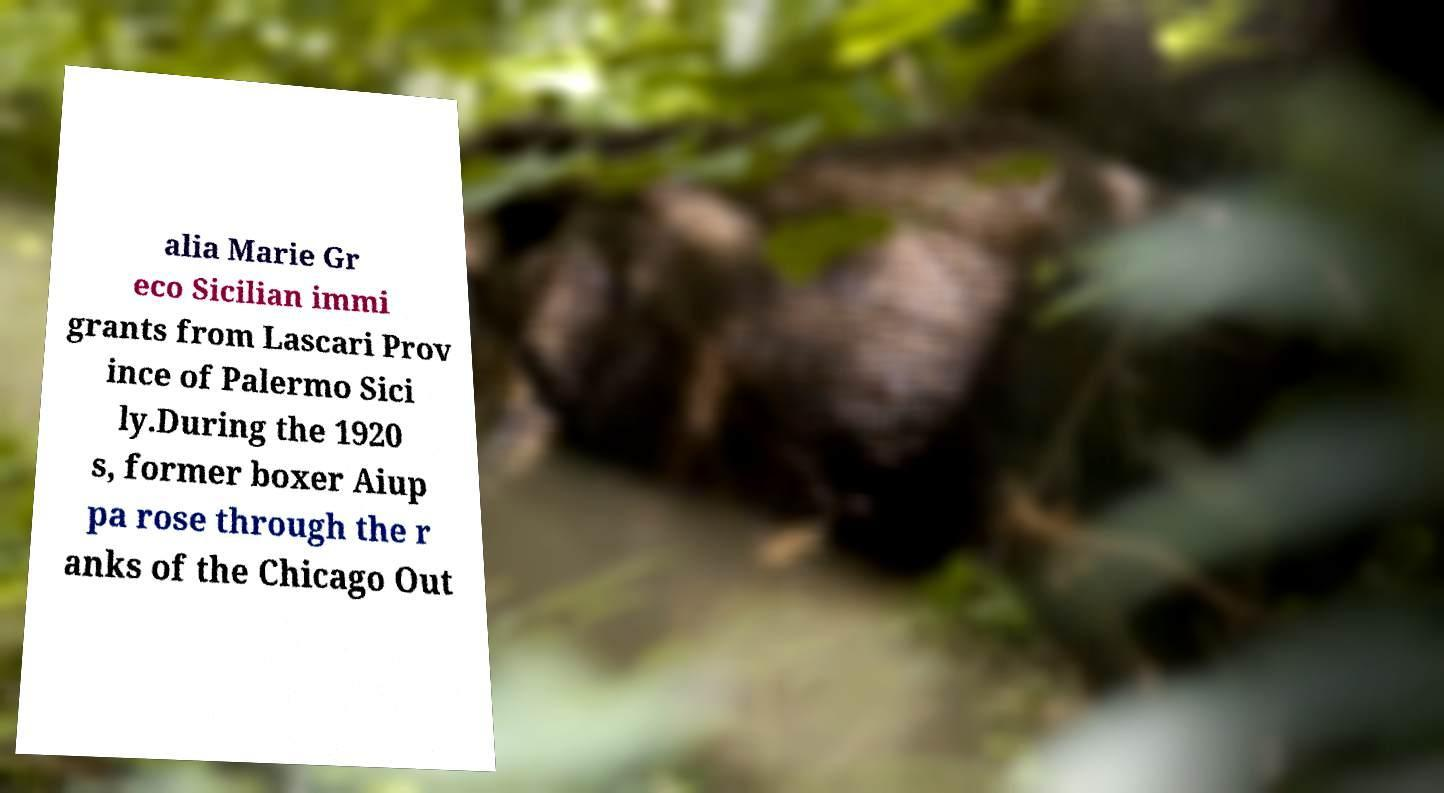Could you assist in decoding the text presented in this image and type it out clearly? alia Marie Gr eco Sicilian immi grants from Lascari Prov ince of Palermo Sici ly.During the 1920 s, former boxer Aiup pa rose through the r anks of the Chicago Out 